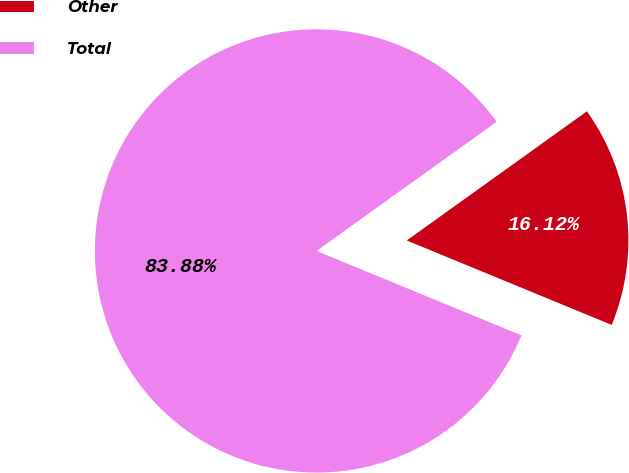<chart> <loc_0><loc_0><loc_500><loc_500><pie_chart><fcel>Other<fcel>Total<nl><fcel>16.12%<fcel>83.88%<nl></chart> 